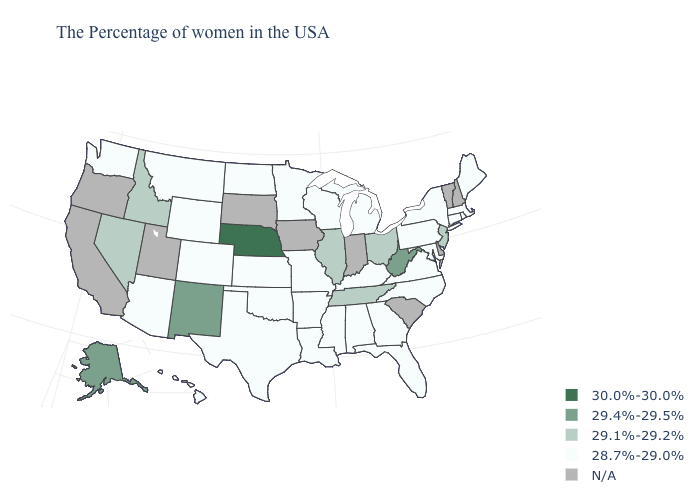What is the value of Maryland?
Keep it brief. 28.7%-29.0%. What is the value of Oregon?
Short answer required. N/A. Name the states that have a value in the range 29.4%-29.5%?
Concise answer only. West Virginia, New Mexico, Alaska. What is the highest value in the Northeast ?
Keep it brief. 29.1%-29.2%. How many symbols are there in the legend?
Keep it brief. 5. Name the states that have a value in the range N/A?
Answer briefly. New Hampshire, Vermont, Delaware, South Carolina, Indiana, Iowa, South Dakota, Utah, California, Oregon. Among the states that border Illinois , which have the lowest value?
Concise answer only. Kentucky, Wisconsin, Missouri. Among the states that border Georgia , which have the highest value?
Give a very brief answer. Tennessee. Is the legend a continuous bar?
Write a very short answer. No. Among the states that border Oklahoma , does Kansas have the lowest value?
Give a very brief answer. Yes. Which states have the highest value in the USA?
Give a very brief answer. Nebraska. What is the value of Georgia?
Be succinct. 28.7%-29.0%. Does New Mexico have the highest value in the West?
Give a very brief answer. Yes. What is the lowest value in states that border Georgia?
Short answer required. 28.7%-29.0%. What is the value of Maine?
Short answer required. 28.7%-29.0%. 